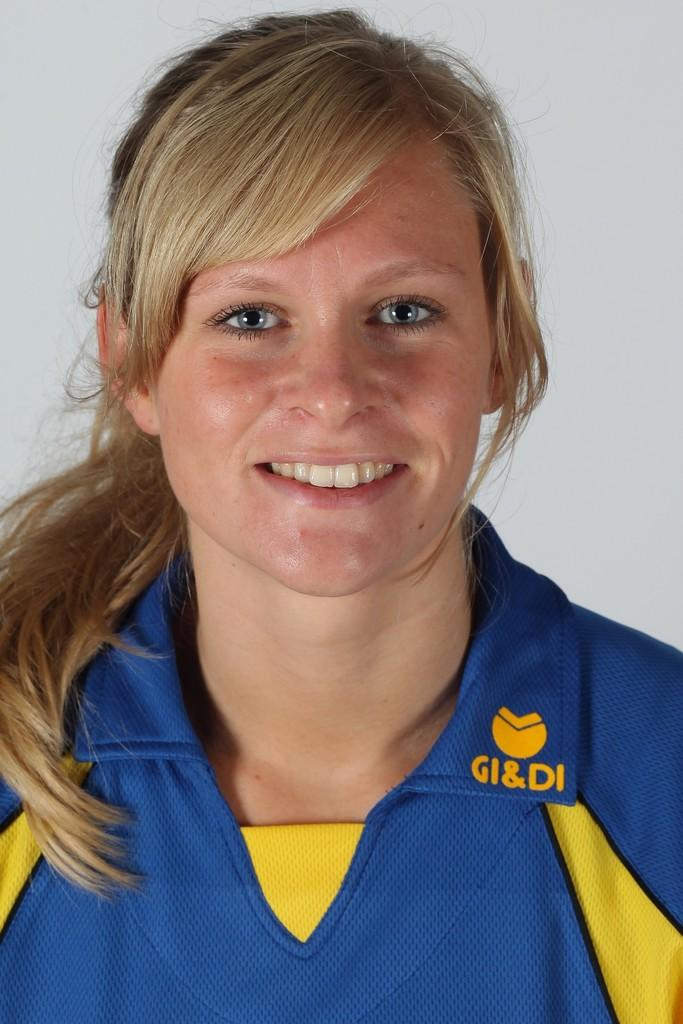<image>
Summarize the visual content of the image. A lady smiling with a blue and yellow shirt on that says GI & DI on it. 